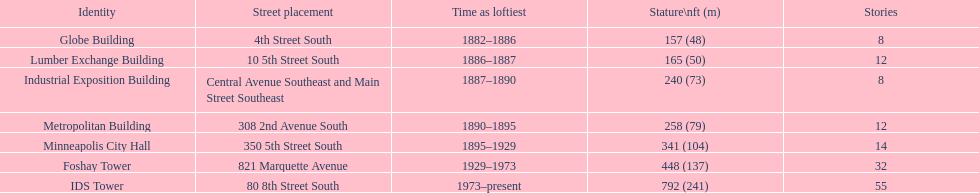Name the tallest building. IDS Tower. 